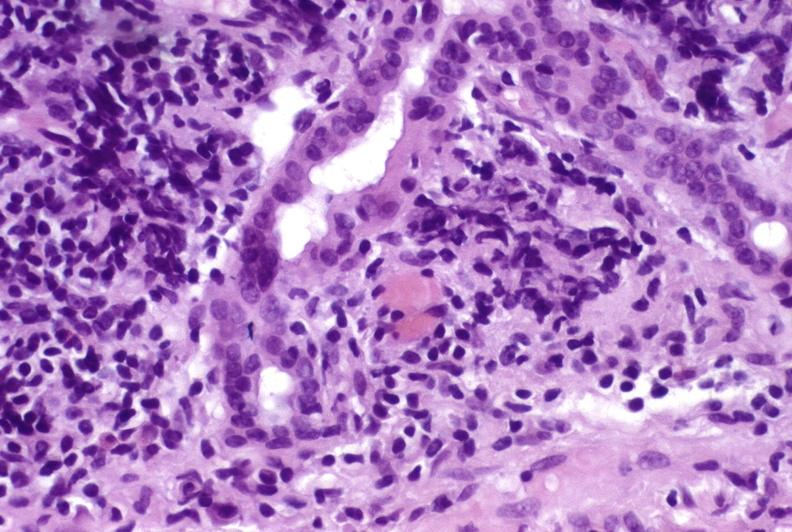s natural color present?
Answer the question using a single word or phrase. No 